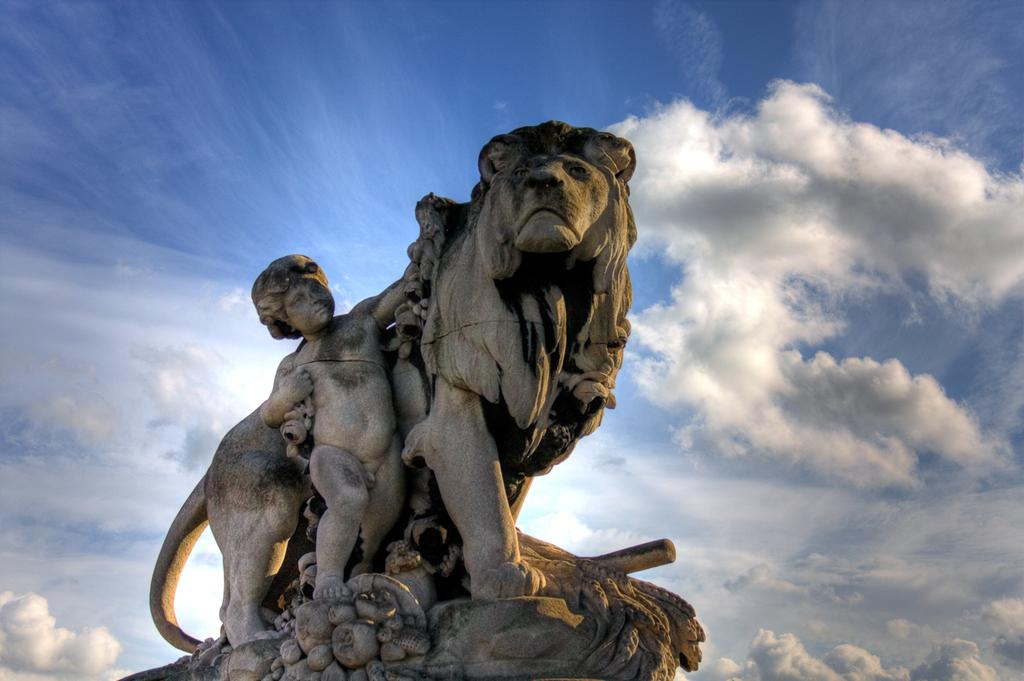What is the main subject of the image? There is a statue of a lion in the image. Can you describe any other elements in the image? There is a child in the image. What time is the child playing the note on the playground in the image? There is no playground or note present in the image, and the child is not playing anything. 